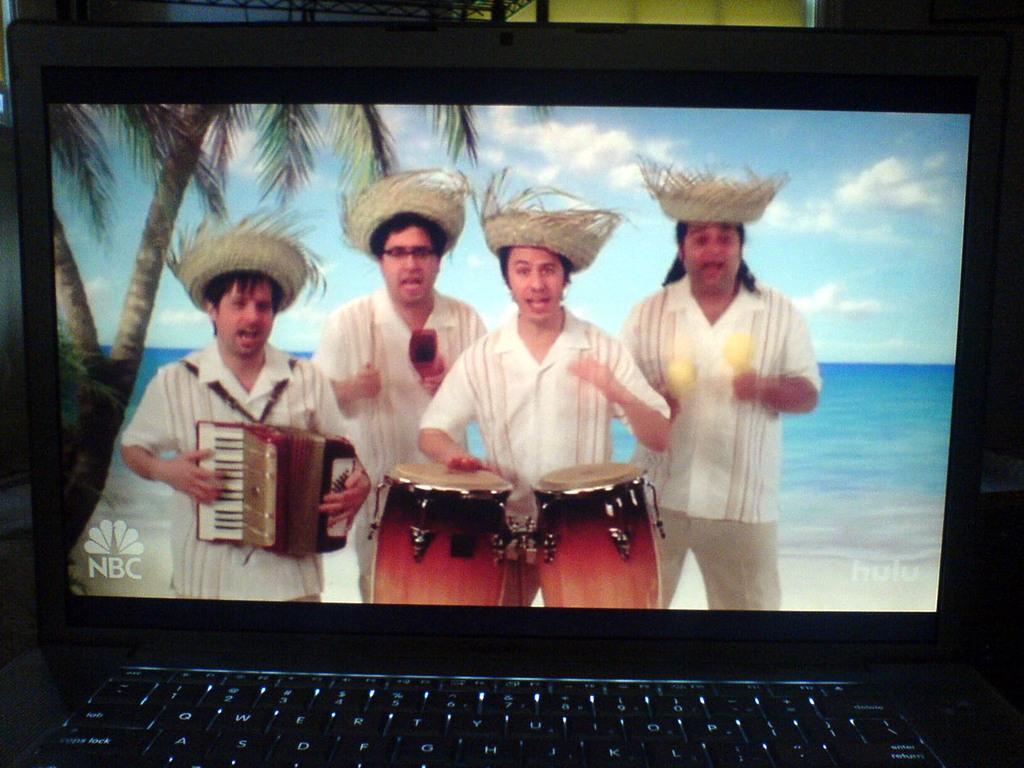Can you describe this image briefly? In this image I can see a laptop, few persons are standing and playing the musical instruments. On the left side there are trees, in the background there is the sea. At the top there is the cloudy sky. 